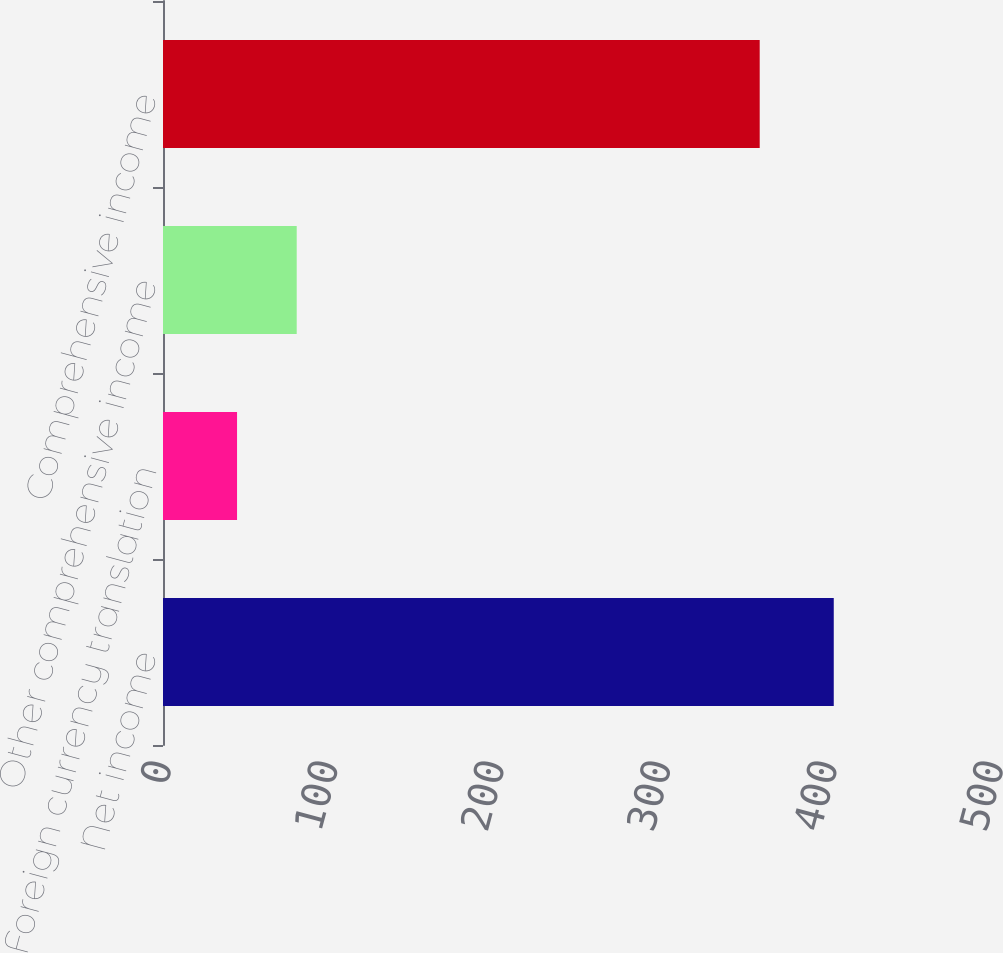Convert chart to OTSL. <chart><loc_0><loc_0><loc_500><loc_500><bar_chart><fcel>Net income<fcel>Foreign currency translation<fcel>Other comprehensive income<fcel>Comprehensive income<nl><fcel>403.1<fcel>44.5<fcel>80.36<fcel>358.6<nl></chart> 